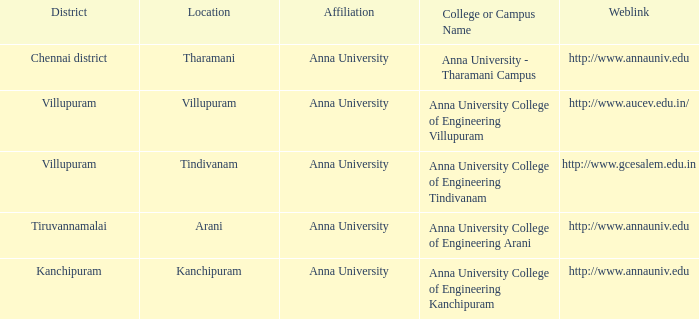What web address includes a college or campus name of anna university college of engineering tindivanam? Http://www.gcesalem.edu.in. 